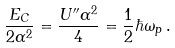Convert formula to latex. <formula><loc_0><loc_0><loc_500><loc_500>\frac { E _ { C } } { 2 \alpha ^ { 2 } } = \frac { U ^ { \prime \prime } \alpha ^ { 2 } } { 4 } = \frac { 1 } { 2 } \hbar { \omega } _ { p } \, .</formula> 